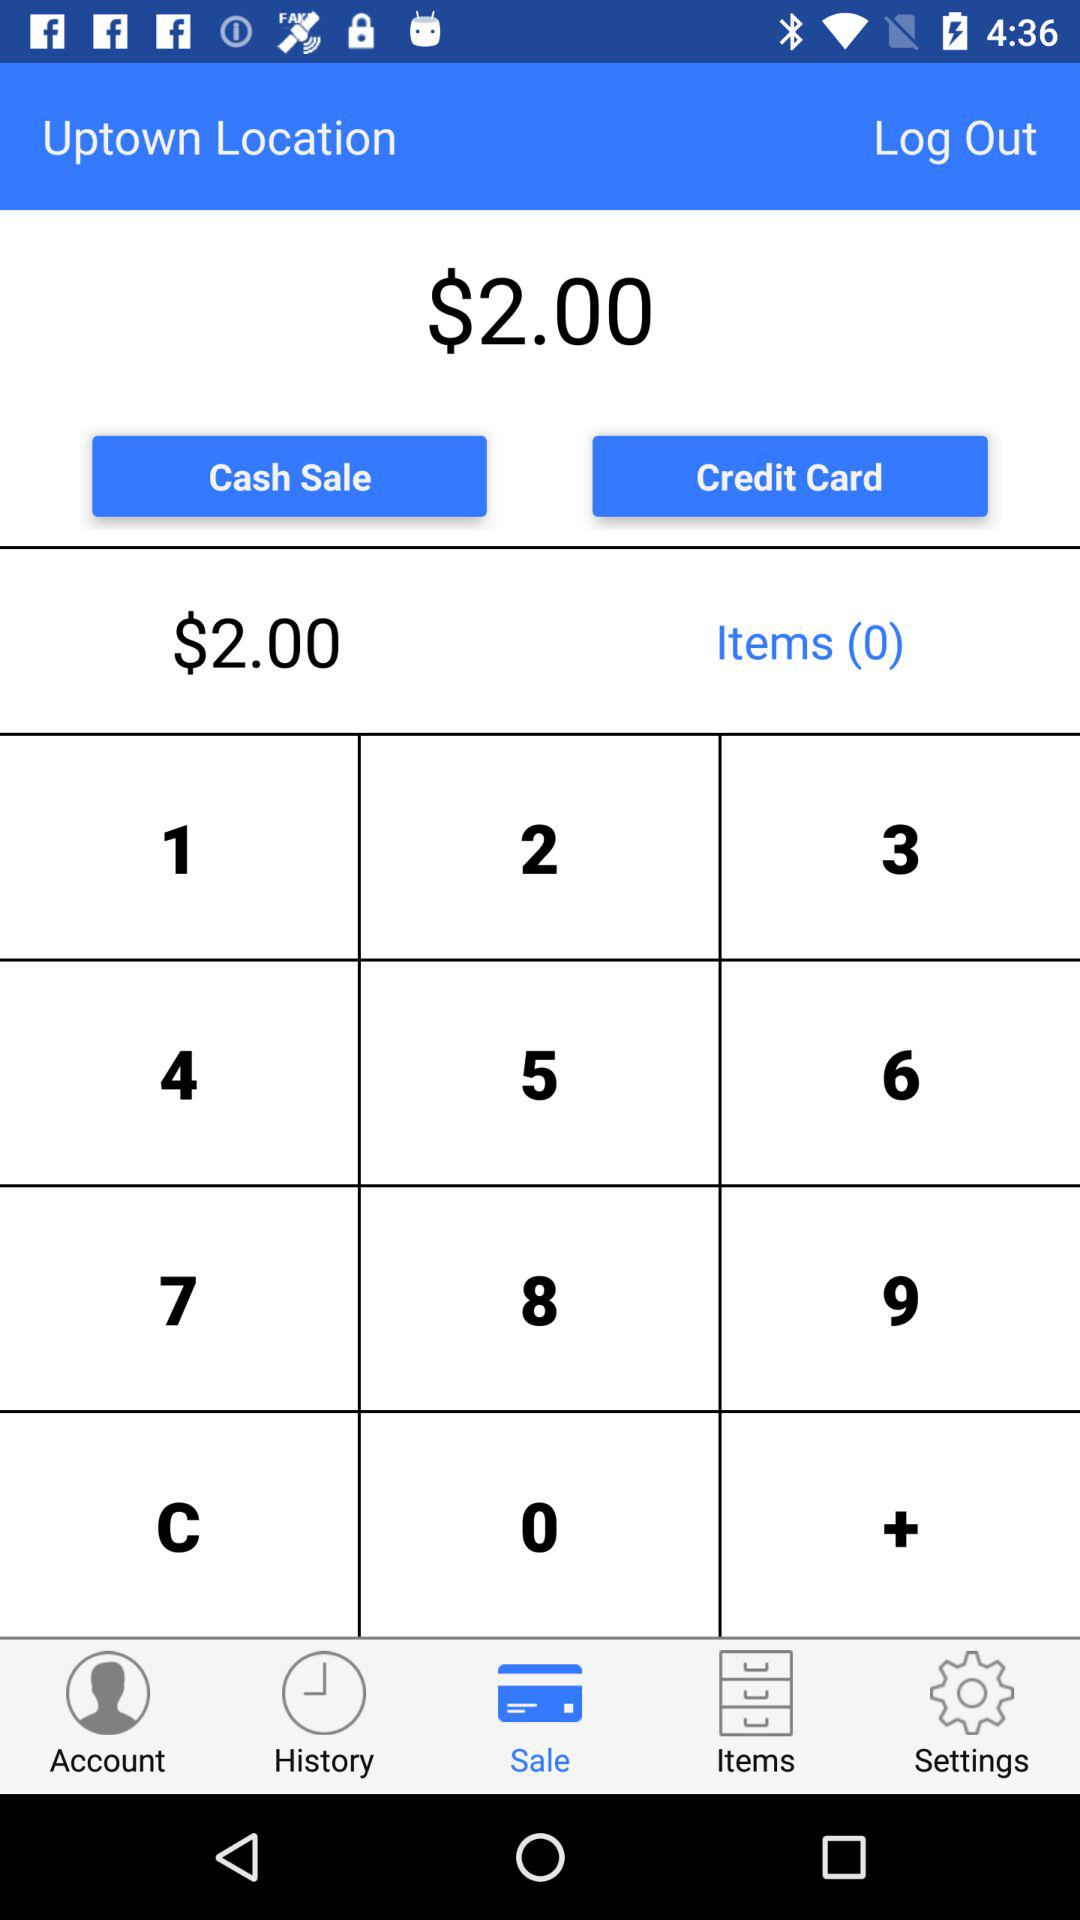Which tab is selected? The selected tab is "Sale". 